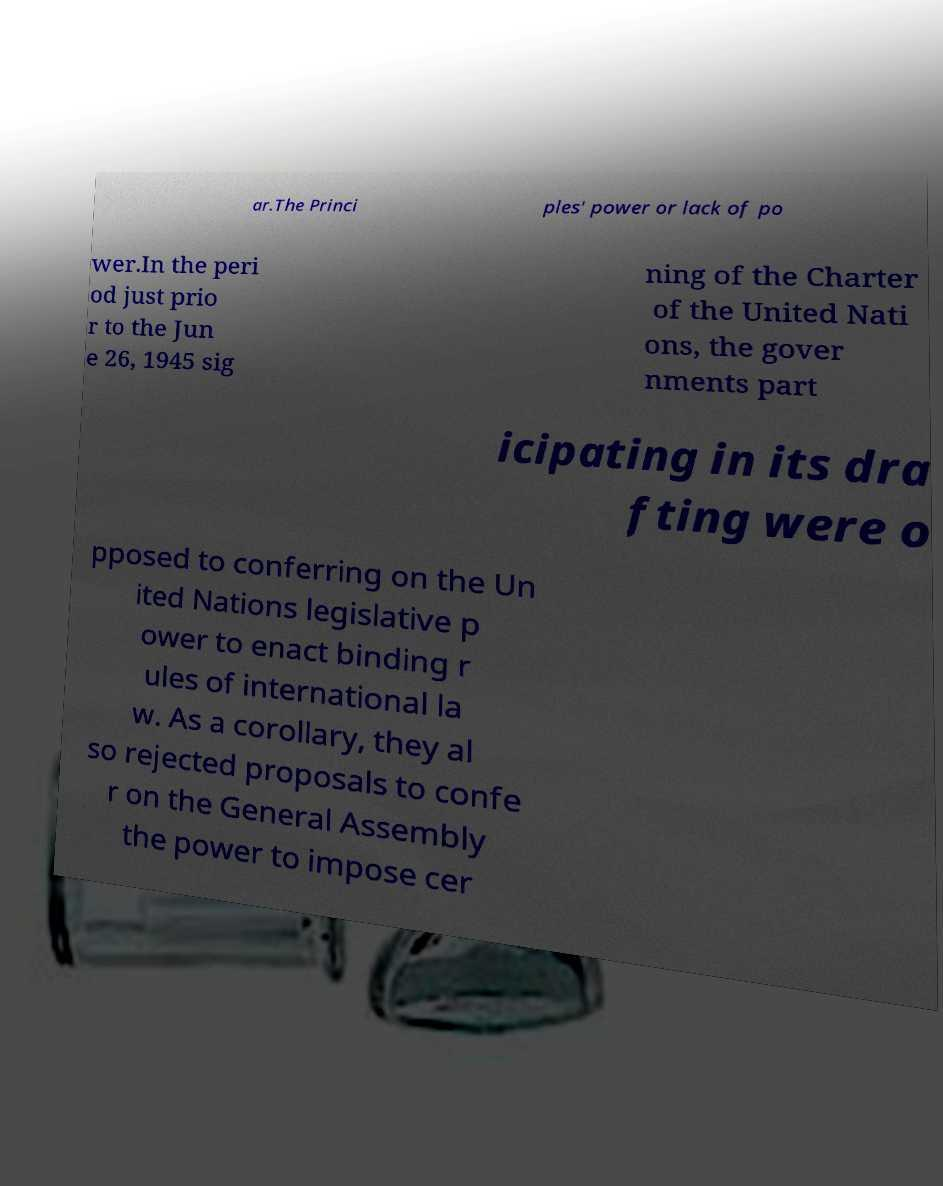Could you assist in decoding the text presented in this image and type it out clearly? ar.The Princi ples' power or lack of po wer.In the peri od just prio r to the Jun e 26, 1945 sig ning of the Charter of the United Nati ons, the gover nments part icipating in its dra fting were o pposed to conferring on the Un ited Nations legislative p ower to enact binding r ules of international la w. As a corollary, they al so rejected proposals to confe r on the General Assembly the power to impose cer 